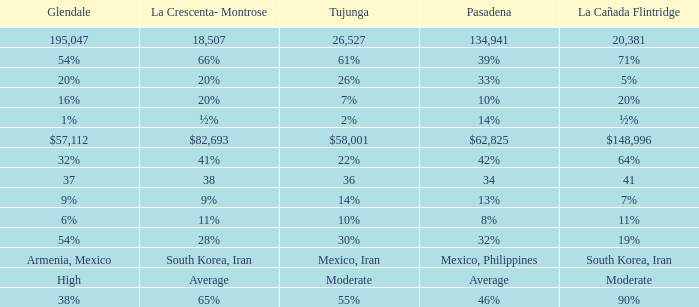What is the figure for Tujunga when Pasadena is 134,941? 26527.0. 